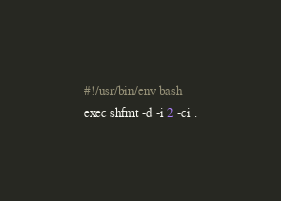Convert code to text. <code><loc_0><loc_0><loc_500><loc_500><_Bash_>#!/usr/bin/env bash

exec shfmt -d -i 2 -ci .
</code> 